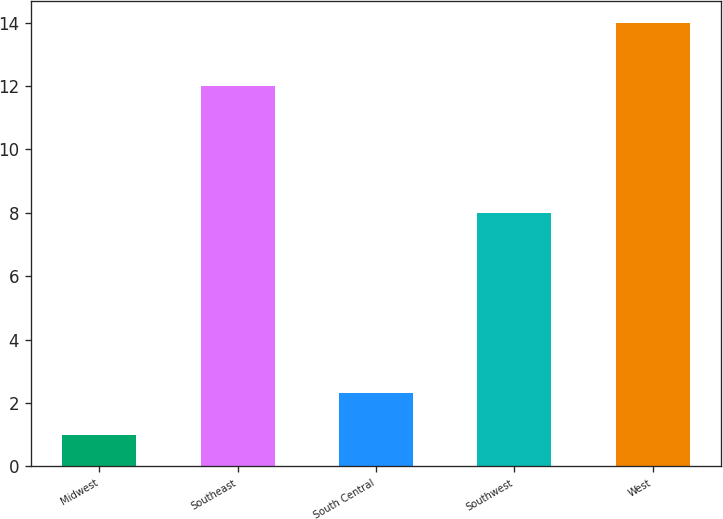Convert chart to OTSL. <chart><loc_0><loc_0><loc_500><loc_500><bar_chart><fcel>Midwest<fcel>Southeast<fcel>South Central<fcel>Southwest<fcel>West<nl><fcel>1<fcel>12<fcel>2.3<fcel>8<fcel>14<nl></chart> 